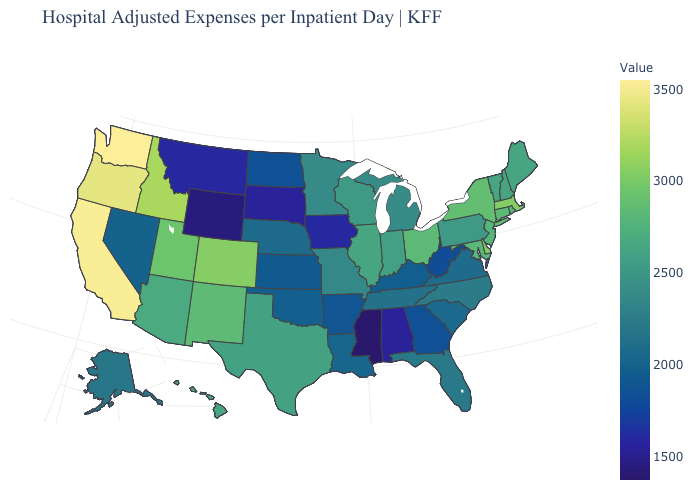Does Mississippi have the lowest value in the USA?
Give a very brief answer. Yes. Among the states that border Oregon , which have the highest value?
Be succinct. Washington. 